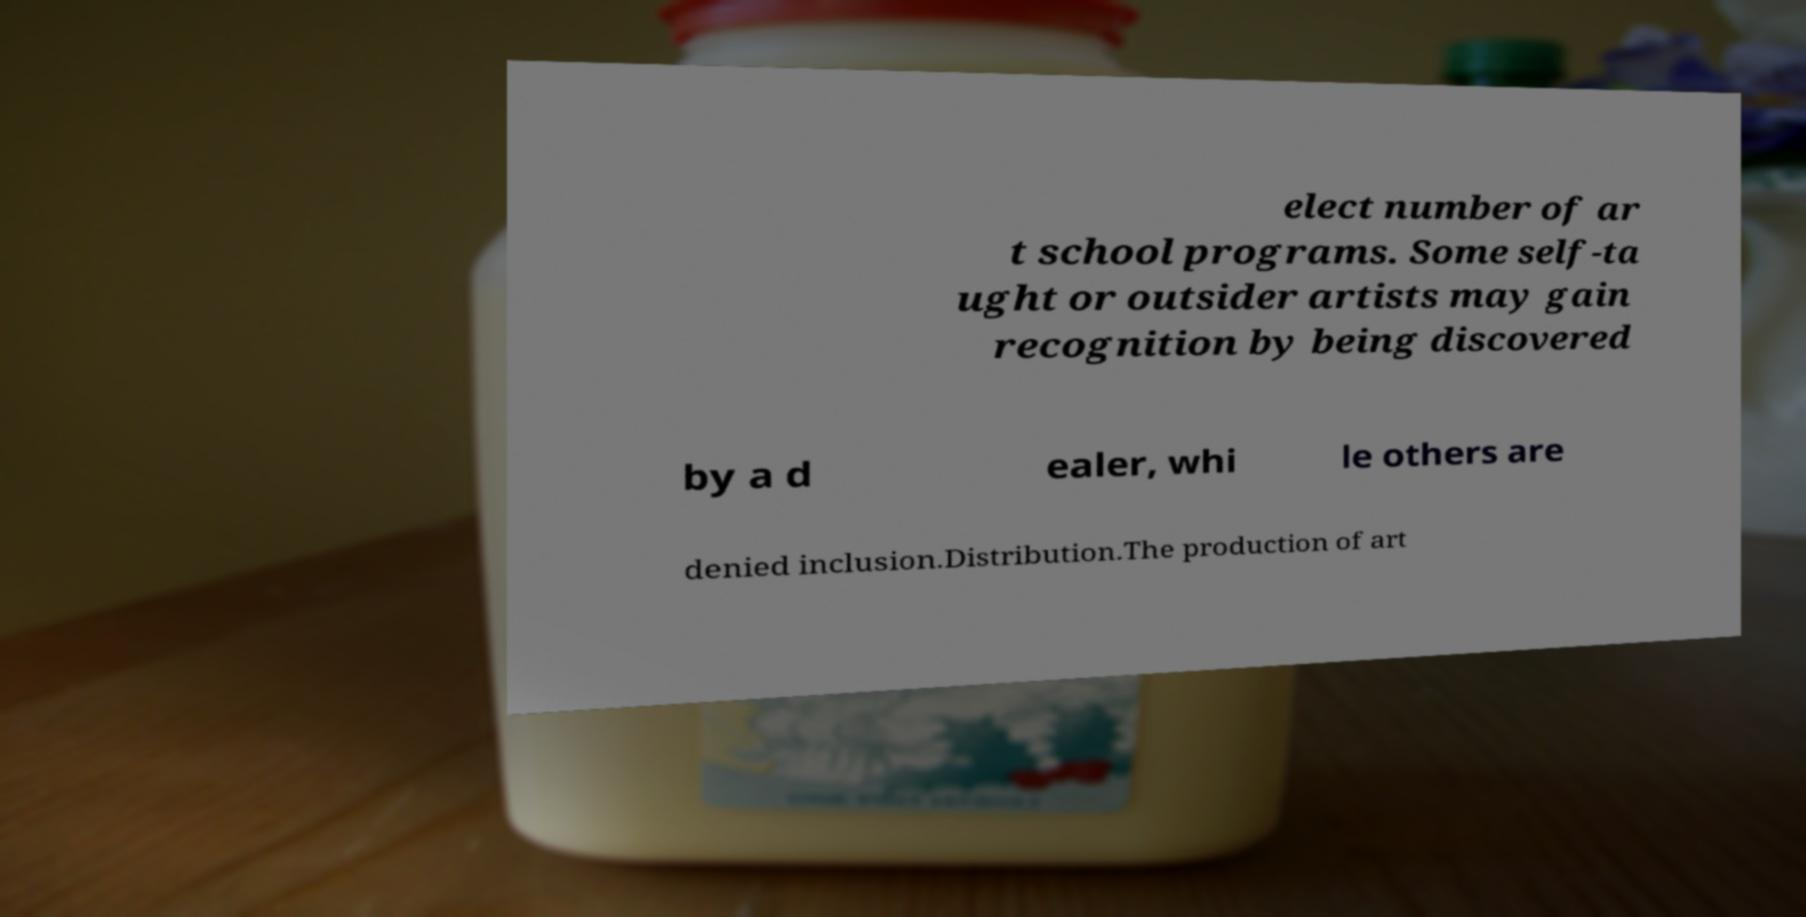Could you assist in decoding the text presented in this image and type it out clearly? elect number of ar t school programs. Some self-ta ught or outsider artists may gain recognition by being discovered by a d ealer, whi le others are denied inclusion.Distribution.The production of art 